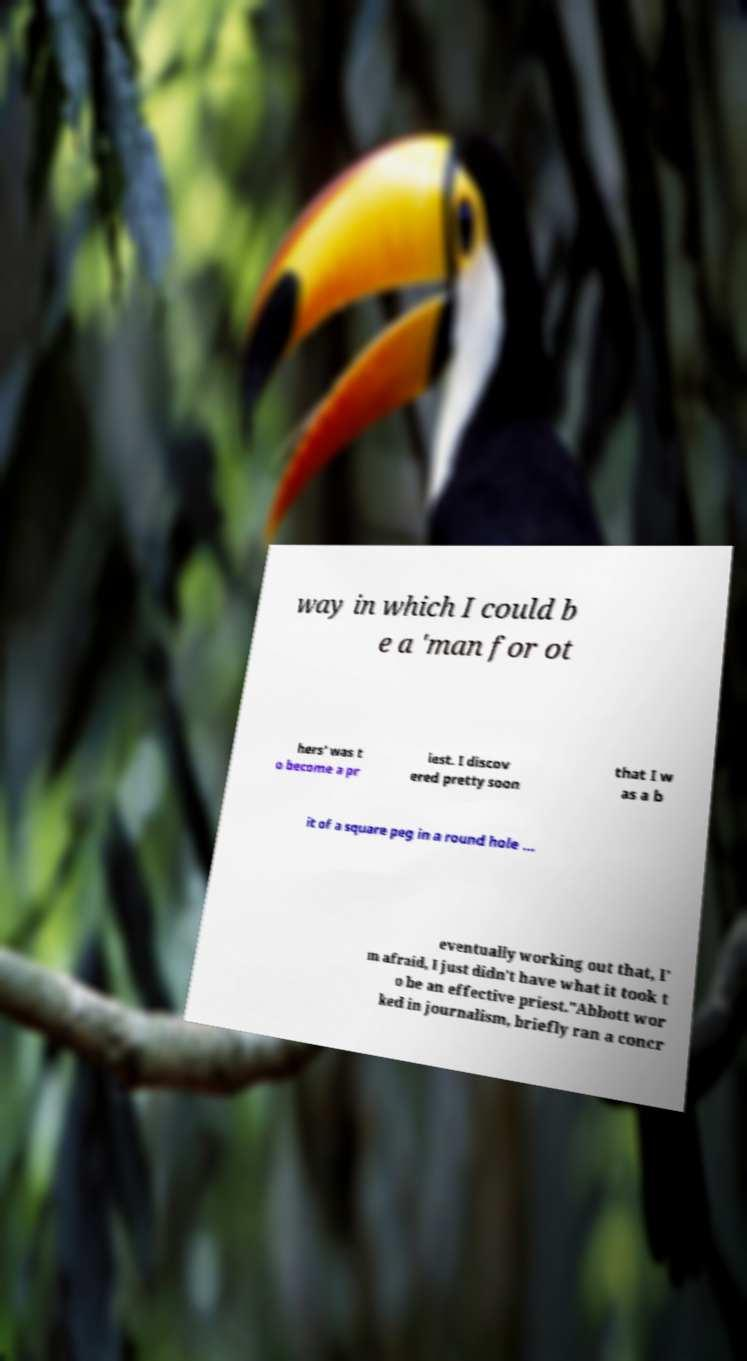I need the written content from this picture converted into text. Can you do that? way in which I could b e a 'man for ot hers' was t o become a pr iest. I discov ered pretty soon that I w as a b it of a square peg in a round hole … eventually working out that, I' m afraid, I just didn't have what it took t o be an effective priest."Abbott wor ked in journalism, briefly ran a concr 